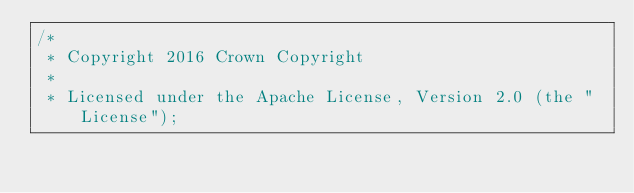Convert code to text. <code><loc_0><loc_0><loc_500><loc_500><_Java_>/*
 * Copyright 2016 Crown Copyright
 *
 * Licensed under the Apache License, Version 2.0 (the "License");</code> 